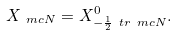<formula> <loc_0><loc_0><loc_500><loc_500>X _ { \ m c { N } } = X ^ { 0 } _ { - \frac { 1 } { 2 } \ t r \ m c { N } } .</formula> 